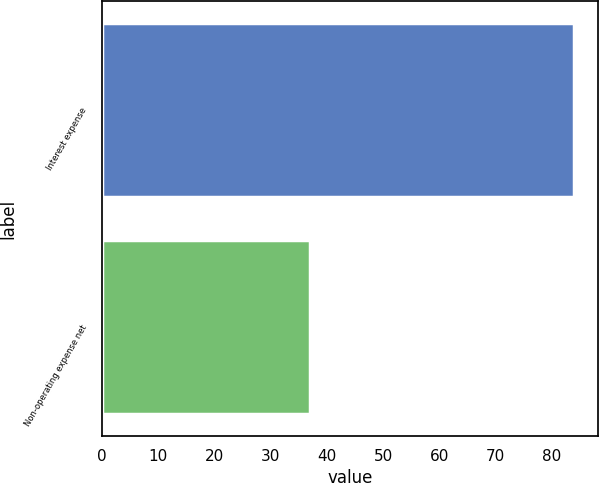Convert chart to OTSL. <chart><loc_0><loc_0><loc_500><loc_500><bar_chart><fcel>Interest expense<fcel>Non-operating expense net<nl><fcel>84<fcel>37<nl></chart> 